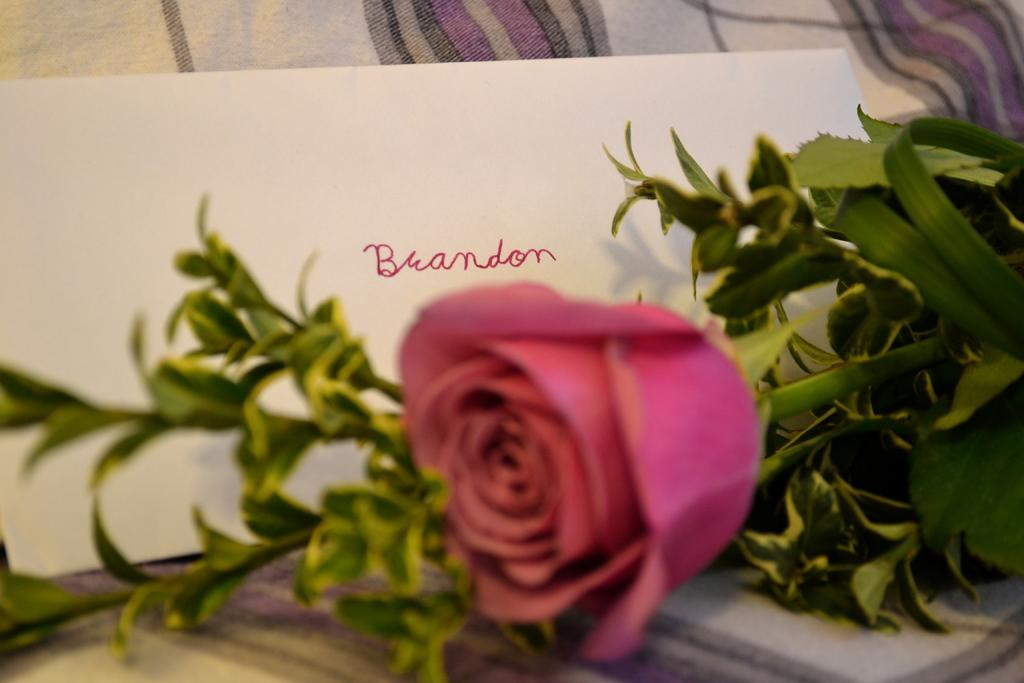What type of plant can be seen in the image? There is a flower in the image. What other object is present on the bed in the image? There is paper on the bed in the image. Can you describe the location of the flower and paper in the image? Both the flower and paper are on a bed. What type of education is being provided by the flower in the image? The flower is not providing any education in the image; it is simply a flower. 